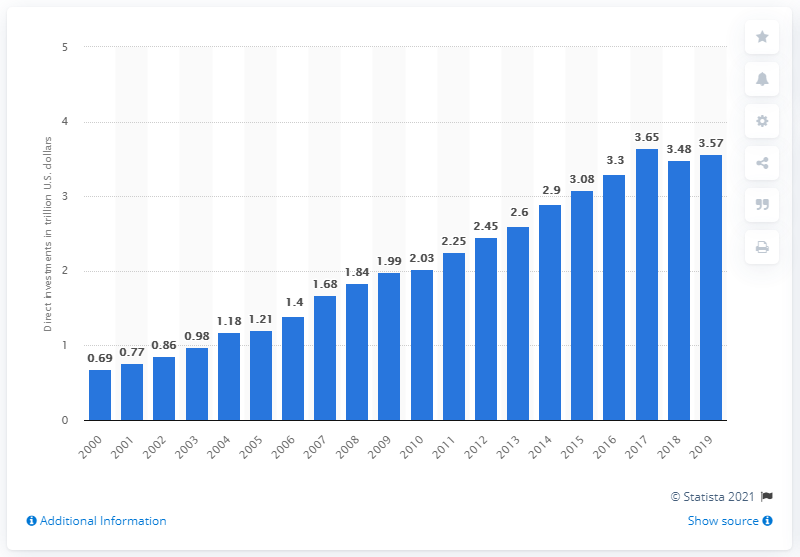Give some essential details in this illustration. The value of U.S. investments made in Europe in 2019 was 3.57... 